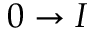Convert formula to latex. <formula><loc_0><loc_0><loc_500><loc_500>0 \rightarrow I</formula> 